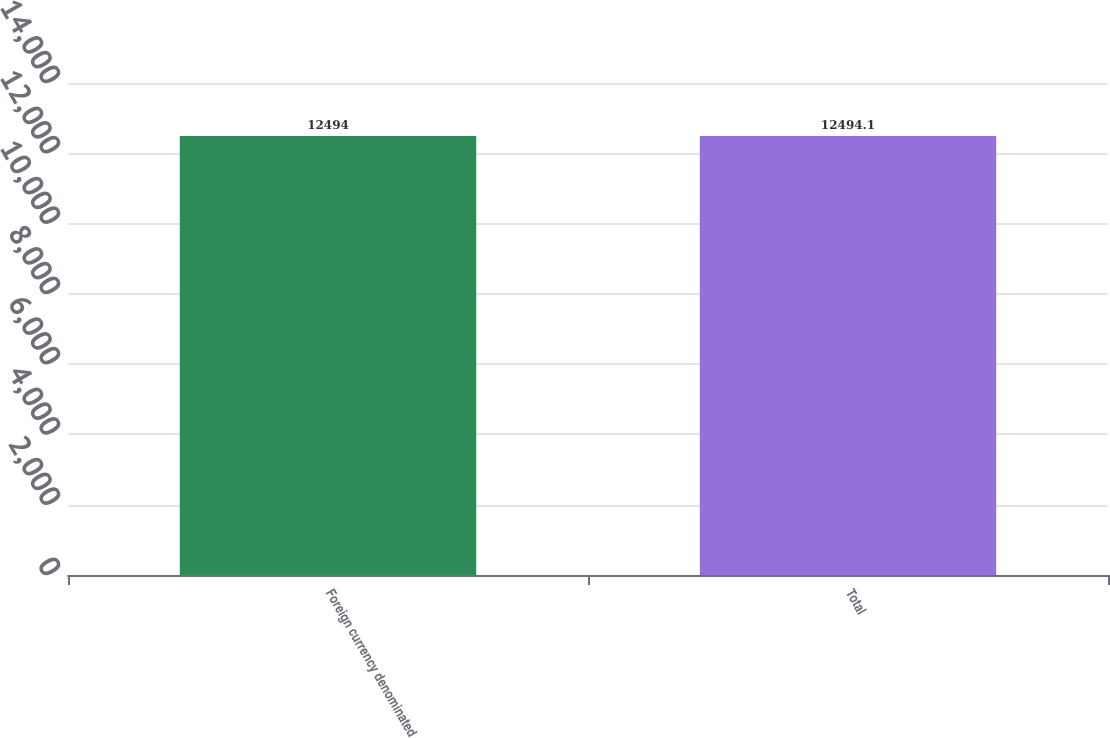Convert chart. <chart><loc_0><loc_0><loc_500><loc_500><bar_chart><fcel>Foreign currency denominated<fcel>Total<nl><fcel>12494<fcel>12494.1<nl></chart> 